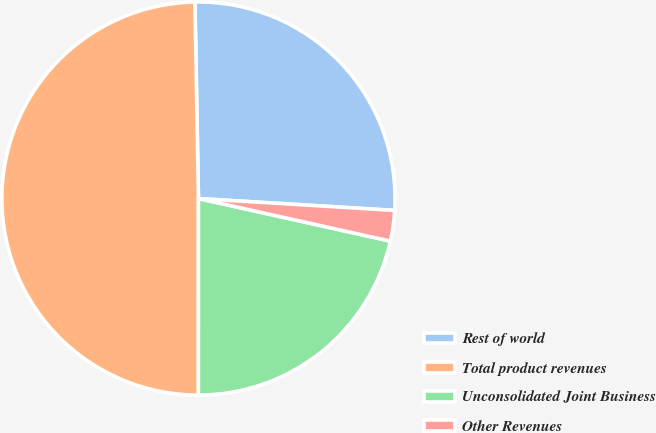<chart> <loc_0><loc_0><loc_500><loc_500><pie_chart><fcel>Rest of world<fcel>Total product revenues<fcel>Unconsolidated Joint Business<fcel>Other Revenues<nl><fcel>26.25%<fcel>49.71%<fcel>21.53%<fcel>2.51%<nl></chart> 